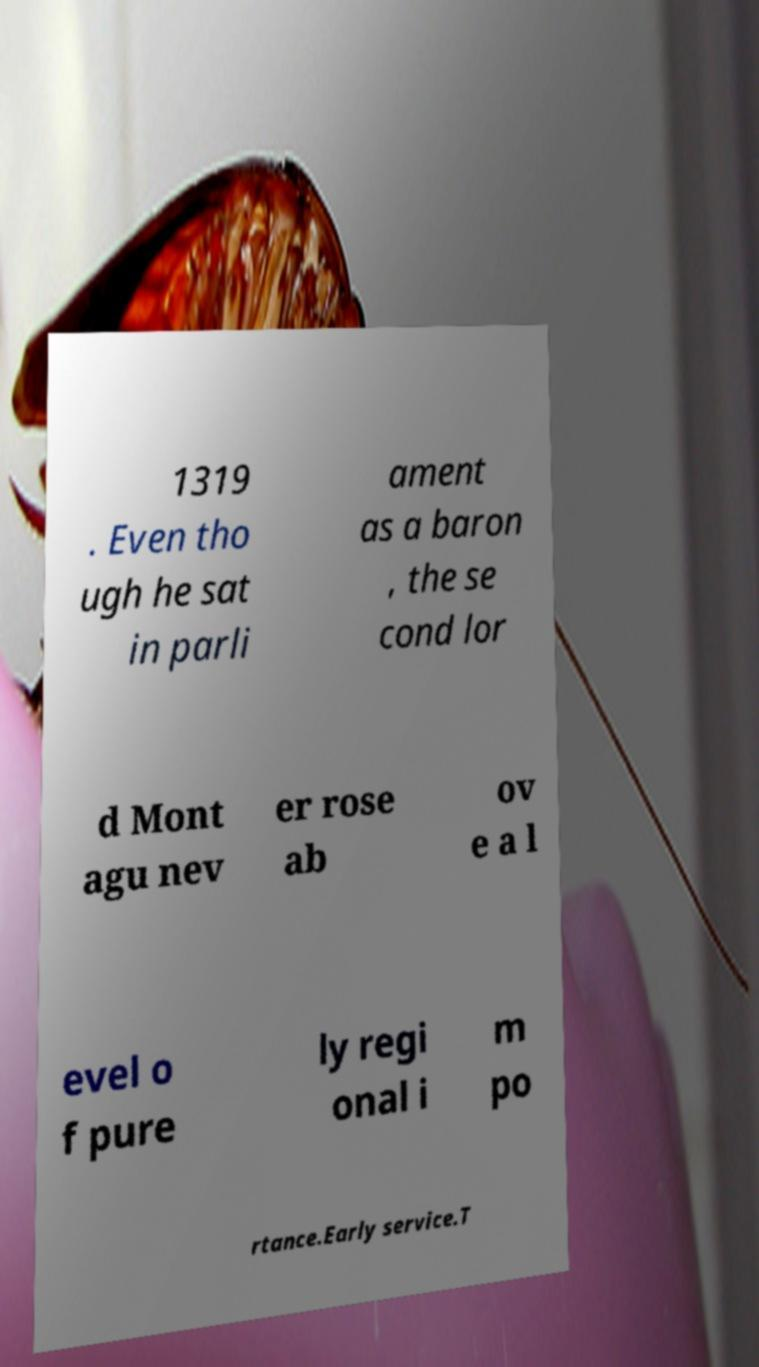For documentation purposes, I need the text within this image transcribed. Could you provide that? 1319 . Even tho ugh he sat in parli ament as a baron , the se cond lor d Mont agu nev er rose ab ov e a l evel o f pure ly regi onal i m po rtance.Early service.T 